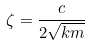<formula> <loc_0><loc_0><loc_500><loc_500>\zeta = \frac { c } { 2 \sqrt { k m } }</formula> 